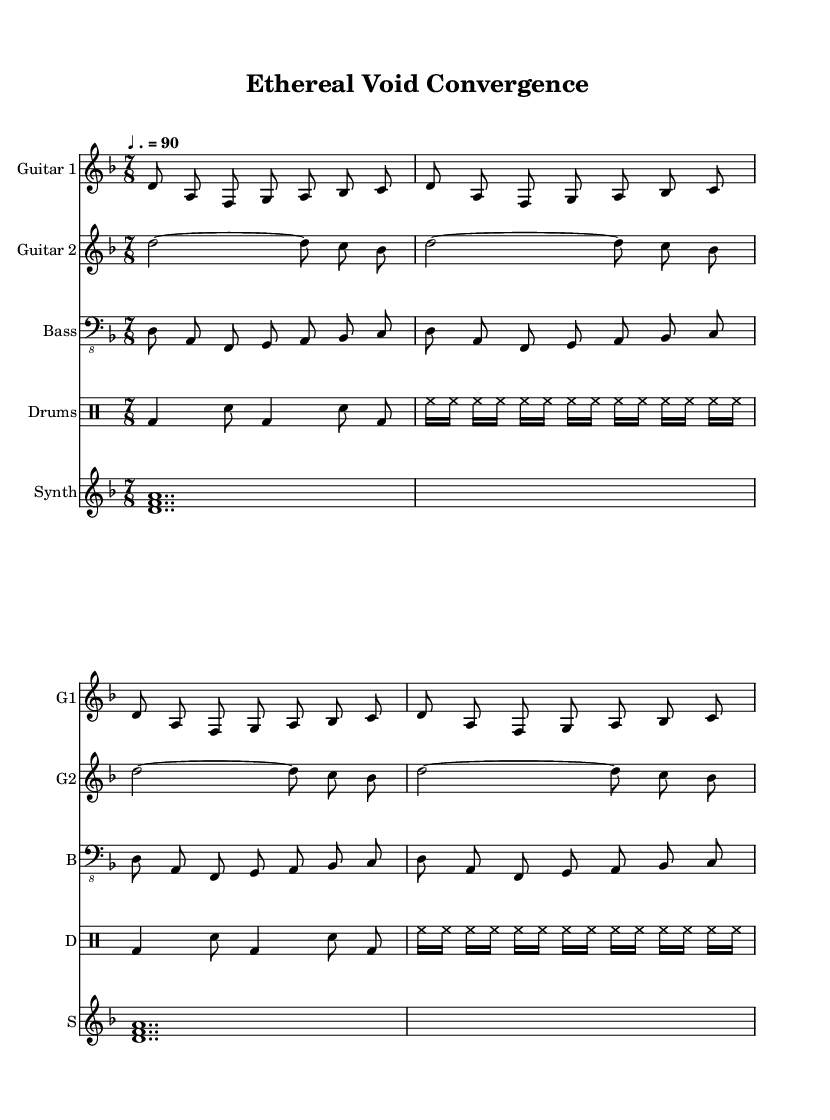What is the key signature of this music? The key signature is indicated at the beginning of the staff, and it shows two flats. Therefore, the key signature corresponds to D minor.
Answer: D minor What is the time signature? The time signature appears after the key signature, displaying 7 over 8. This indicates that each measure contains seven eighth-note beats.
Answer: 7/8 What is the tempo marking for the piece? The tempo marking is located above the staff and indicates the pace of the music. It shows a quarter note equals 90 beats per minute.
Answer: ♩. = 90 How many times does the phrase in Guitar 1 repeat? By examining the Guitar 1 staff, the same four-bar phrase is repeated four times in succession across the staff.
Answer: 4 What type of sound does the Synth produce? The Synth part consists of sustained notes, producing a pad-like texture, which creates an atmospheric soundscape that is characteristic in avant-garde black metal.
Answer: Atmospheric What is the purpose of the drum part's rhythm variation? The drum part uses alternating rhythms, contrasting standard beats with syncopation to enhance the dynamic quality and atmospheric feel of the piece, which is crucial for creating tension in metal music.
Answer: Enhancing tension What do the two guitars signify in the arrangement? The two guitars provide a layered textural arrangement, with one playing a melodic line while the other plays sustained notes, indicative of experimentation prevalent in avant-garde black metal.
Answer: Layered textures 